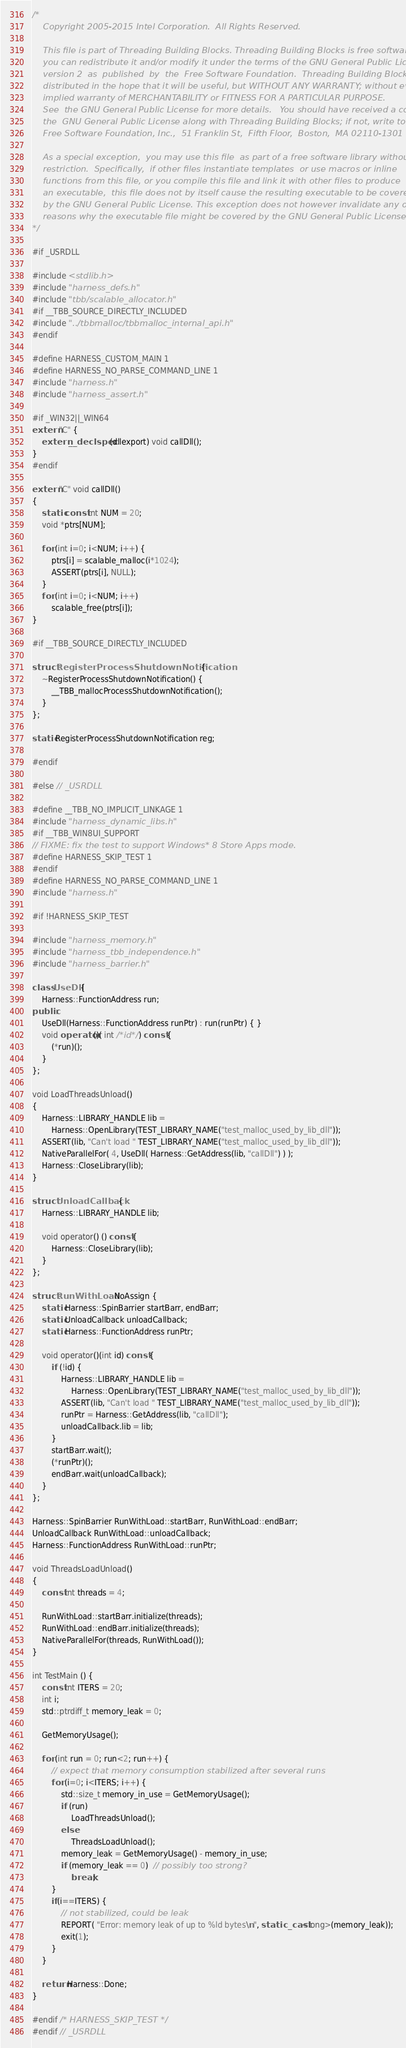<code> <loc_0><loc_0><loc_500><loc_500><_C++_>/*
    Copyright 2005-2015 Intel Corporation.  All Rights Reserved.

    This file is part of Threading Building Blocks. Threading Building Blocks is free software;
    you can redistribute it and/or modify it under the terms of the GNU General Public License
    version 2  as  published  by  the  Free Software Foundation.  Threading Building Blocks is
    distributed in the hope that it will be useful, but WITHOUT ANY WARRANTY; without even the
    implied warranty of MERCHANTABILITY or FITNESS FOR A PARTICULAR PURPOSE.
    See  the GNU General Public License for more details.   You should have received a copy of
    the  GNU General Public License along with Threading Building Blocks; if not, write to the
    Free Software Foundation, Inc.,  51 Franklin St,  Fifth Floor,  Boston,  MA 02110-1301 USA

    As a special exception,  you may use this file  as part of a free software library without
    restriction.  Specifically,  if other files instantiate templates  or use macros or inline
    functions from this file, or you compile this file and link it with other files to produce
    an executable,  this file does not by itself cause the resulting executable to be covered
    by the GNU General Public License. This exception does not however invalidate any other
    reasons why the executable file might be covered by the GNU General Public License.
*/

#if _USRDLL

#include <stdlib.h>
#include "harness_defs.h"
#include "tbb/scalable_allocator.h"
#if __TBB_SOURCE_DIRECTLY_INCLUDED
#include "../tbbmalloc/tbbmalloc_internal_api.h"
#endif

#define HARNESS_CUSTOM_MAIN 1
#define HARNESS_NO_PARSE_COMMAND_LINE 1
#include "harness.h"
#include "harness_assert.h"

#if _WIN32||_WIN64
extern "C" {
    extern __declspec(dllexport) void callDll();
}
#endif

extern "C" void callDll()
{
    static const int NUM = 20;
    void *ptrs[NUM];

    for (int i=0; i<NUM; i++) {
        ptrs[i] = scalable_malloc(i*1024);
        ASSERT(ptrs[i], NULL);
    }
    for (int i=0; i<NUM; i++)
        scalable_free(ptrs[i]);
}

#if __TBB_SOURCE_DIRECTLY_INCLUDED

struct RegisterProcessShutdownNotification {
    ~RegisterProcessShutdownNotification() {
        __TBB_mallocProcessShutdownNotification();
    }
};

static RegisterProcessShutdownNotification reg;

#endif

#else // _USRDLL

#define __TBB_NO_IMPLICIT_LINKAGE 1
#include "harness_dynamic_libs.h"
#if __TBB_WIN8UI_SUPPORT
// FIXME: fix the test to support Windows* 8 Store Apps mode.
#define HARNESS_SKIP_TEST 1
#endif
#define HARNESS_NO_PARSE_COMMAND_LINE 1
#include "harness.h"

#if !HARNESS_SKIP_TEST

#include "harness_memory.h"
#include "harness_tbb_independence.h"
#include "harness_barrier.h"

class UseDll {
    Harness::FunctionAddress run;
public:
    UseDll(Harness::FunctionAddress runPtr) : run(runPtr) { }
    void operator()( int /*id*/ ) const {
        (*run)();
    }
};

void LoadThreadsUnload()
{
    Harness::LIBRARY_HANDLE lib =
        Harness::OpenLibrary(TEST_LIBRARY_NAME("test_malloc_used_by_lib_dll"));
    ASSERT(lib, "Can't load " TEST_LIBRARY_NAME("test_malloc_used_by_lib_dll"));
    NativeParallelFor( 4, UseDll( Harness::GetAddress(lib, "callDll") ) );
    Harness::CloseLibrary(lib);
}

struct UnloadCallback {
    Harness::LIBRARY_HANDLE lib;

    void operator() () const {
        Harness::CloseLibrary(lib);
    }
};

struct RunWithLoad : NoAssign {
    static Harness::SpinBarrier startBarr, endBarr;
    static UnloadCallback unloadCallback;
    static Harness::FunctionAddress runPtr;

    void operator()(int id) const {
        if (!id) {
            Harness::LIBRARY_HANDLE lib =
                Harness::OpenLibrary(TEST_LIBRARY_NAME("test_malloc_used_by_lib_dll"));
            ASSERT(lib, "Can't load " TEST_LIBRARY_NAME("test_malloc_used_by_lib_dll"));
            runPtr = Harness::GetAddress(lib, "callDll");
            unloadCallback.lib = lib;
        }
        startBarr.wait();
        (*runPtr)();
        endBarr.wait(unloadCallback);
    }
};

Harness::SpinBarrier RunWithLoad::startBarr, RunWithLoad::endBarr;
UnloadCallback RunWithLoad::unloadCallback;
Harness::FunctionAddress RunWithLoad::runPtr;

void ThreadsLoadUnload()
{
    const int threads = 4;

    RunWithLoad::startBarr.initialize(threads);
    RunWithLoad::endBarr.initialize(threads);
    NativeParallelFor(threads, RunWithLoad());
}

int TestMain () {
    const int ITERS = 20;
    int i;
    std::ptrdiff_t memory_leak = 0;

    GetMemoryUsage();

    for (int run = 0; run<2; run++) {
        // expect that memory consumption stabilized after several runs
        for (i=0; i<ITERS; i++) {
            std::size_t memory_in_use = GetMemoryUsage();
            if (run)
                LoadThreadsUnload();
            else
                ThreadsLoadUnload();
            memory_leak = GetMemoryUsage() - memory_in_use;
            if (memory_leak == 0)  // possibly too strong?
                break;
        }
        if(i==ITERS) {
            // not stabilized, could be leak
            REPORT( "Error: memory leak of up to %ld bytes\n", static_cast<long>(memory_leak));
            exit(1);
        }
    }

    return Harness::Done;
}

#endif /* HARNESS_SKIP_TEST */
#endif // _USRDLL
</code> 